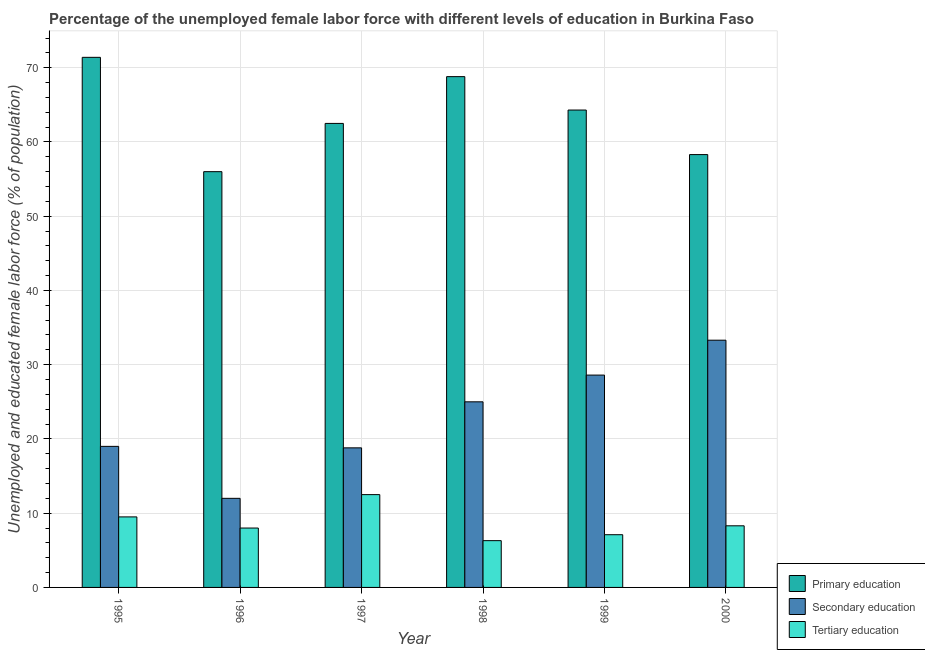How many different coloured bars are there?
Give a very brief answer. 3. Are the number of bars on each tick of the X-axis equal?
Your answer should be very brief. Yes. How many bars are there on the 4th tick from the right?
Offer a terse response. 3. What is the label of the 6th group of bars from the left?
Ensure brevity in your answer.  2000. In how many cases, is the number of bars for a given year not equal to the number of legend labels?
Give a very brief answer. 0. What is the percentage of female labor force who received tertiary education in 1999?
Keep it short and to the point. 7.1. Across all years, what is the minimum percentage of female labor force who received secondary education?
Your answer should be compact. 12. In which year was the percentage of female labor force who received secondary education minimum?
Ensure brevity in your answer.  1996. What is the total percentage of female labor force who received primary education in the graph?
Your answer should be compact. 381.3. What is the difference between the percentage of female labor force who received secondary education in 1996 and the percentage of female labor force who received tertiary education in 1995?
Keep it short and to the point. -7. What is the average percentage of female labor force who received tertiary education per year?
Your response must be concise. 8.62. In the year 2000, what is the difference between the percentage of female labor force who received tertiary education and percentage of female labor force who received primary education?
Keep it short and to the point. 0. In how many years, is the percentage of female labor force who received primary education greater than 32 %?
Make the answer very short. 6. What is the ratio of the percentage of female labor force who received primary education in 1996 to that in 2000?
Make the answer very short. 0.96. Is the percentage of female labor force who received tertiary education in 1995 less than that in 2000?
Offer a very short reply. No. What is the difference between the highest and the second highest percentage of female labor force who received tertiary education?
Your answer should be very brief. 3. What is the difference between the highest and the lowest percentage of female labor force who received tertiary education?
Ensure brevity in your answer.  6.2. What does the 1st bar from the left in 2000 represents?
Keep it short and to the point. Primary education. What does the 3rd bar from the right in 2000 represents?
Your answer should be very brief. Primary education. Are all the bars in the graph horizontal?
Provide a succinct answer. No. Are the values on the major ticks of Y-axis written in scientific E-notation?
Your answer should be compact. No. Does the graph contain any zero values?
Offer a terse response. No. How many legend labels are there?
Your answer should be very brief. 3. What is the title of the graph?
Your answer should be compact. Percentage of the unemployed female labor force with different levels of education in Burkina Faso. What is the label or title of the Y-axis?
Offer a terse response. Unemployed and educated female labor force (% of population). What is the Unemployed and educated female labor force (% of population) of Primary education in 1995?
Offer a very short reply. 71.4. What is the Unemployed and educated female labor force (% of population) of Tertiary education in 1995?
Offer a very short reply. 9.5. What is the Unemployed and educated female labor force (% of population) in Primary education in 1996?
Provide a succinct answer. 56. What is the Unemployed and educated female labor force (% of population) of Secondary education in 1996?
Offer a very short reply. 12. What is the Unemployed and educated female labor force (% of population) of Primary education in 1997?
Make the answer very short. 62.5. What is the Unemployed and educated female labor force (% of population) of Secondary education in 1997?
Provide a succinct answer. 18.8. What is the Unemployed and educated female labor force (% of population) of Tertiary education in 1997?
Provide a succinct answer. 12.5. What is the Unemployed and educated female labor force (% of population) in Primary education in 1998?
Your response must be concise. 68.8. What is the Unemployed and educated female labor force (% of population) of Secondary education in 1998?
Provide a short and direct response. 25. What is the Unemployed and educated female labor force (% of population) in Tertiary education in 1998?
Your response must be concise. 6.3. What is the Unemployed and educated female labor force (% of population) in Primary education in 1999?
Provide a succinct answer. 64.3. What is the Unemployed and educated female labor force (% of population) of Secondary education in 1999?
Make the answer very short. 28.6. What is the Unemployed and educated female labor force (% of population) of Tertiary education in 1999?
Provide a succinct answer. 7.1. What is the Unemployed and educated female labor force (% of population) in Primary education in 2000?
Keep it short and to the point. 58.3. What is the Unemployed and educated female labor force (% of population) of Secondary education in 2000?
Ensure brevity in your answer.  33.3. What is the Unemployed and educated female labor force (% of population) of Tertiary education in 2000?
Offer a terse response. 8.3. Across all years, what is the maximum Unemployed and educated female labor force (% of population) in Primary education?
Your answer should be very brief. 71.4. Across all years, what is the maximum Unemployed and educated female labor force (% of population) of Secondary education?
Make the answer very short. 33.3. Across all years, what is the maximum Unemployed and educated female labor force (% of population) of Tertiary education?
Offer a very short reply. 12.5. Across all years, what is the minimum Unemployed and educated female labor force (% of population) in Tertiary education?
Ensure brevity in your answer.  6.3. What is the total Unemployed and educated female labor force (% of population) of Primary education in the graph?
Provide a short and direct response. 381.3. What is the total Unemployed and educated female labor force (% of population) of Secondary education in the graph?
Make the answer very short. 136.7. What is the total Unemployed and educated female labor force (% of population) in Tertiary education in the graph?
Provide a short and direct response. 51.7. What is the difference between the Unemployed and educated female labor force (% of population) of Secondary education in 1995 and that in 1996?
Provide a succinct answer. 7. What is the difference between the Unemployed and educated female labor force (% of population) in Tertiary education in 1995 and that in 1996?
Provide a short and direct response. 1.5. What is the difference between the Unemployed and educated female labor force (% of population) of Tertiary education in 1995 and that in 1997?
Ensure brevity in your answer.  -3. What is the difference between the Unemployed and educated female labor force (% of population) in Secondary education in 1995 and that in 1998?
Make the answer very short. -6. What is the difference between the Unemployed and educated female labor force (% of population) in Primary education in 1995 and that in 1999?
Your answer should be very brief. 7.1. What is the difference between the Unemployed and educated female labor force (% of population) of Secondary education in 1995 and that in 1999?
Your answer should be compact. -9.6. What is the difference between the Unemployed and educated female labor force (% of population) of Primary education in 1995 and that in 2000?
Your response must be concise. 13.1. What is the difference between the Unemployed and educated female labor force (% of population) of Secondary education in 1995 and that in 2000?
Make the answer very short. -14.3. What is the difference between the Unemployed and educated female labor force (% of population) of Primary education in 1996 and that in 1997?
Your answer should be very brief. -6.5. What is the difference between the Unemployed and educated female labor force (% of population) of Primary education in 1996 and that in 1998?
Give a very brief answer. -12.8. What is the difference between the Unemployed and educated female labor force (% of population) of Primary education in 1996 and that in 1999?
Make the answer very short. -8.3. What is the difference between the Unemployed and educated female labor force (% of population) of Secondary education in 1996 and that in 1999?
Keep it short and to the point. -16.6. What is the difference between the Unemployed and educated female labor force (% of population) of Secondary education in 1996 and that in 2000?
Offer a very short reply. -21.3. What is the difference between the Unemployed and educated female labor force (% of population) in Tertiary education in 1996 and that in 2000?
Make the answer very short. -0.3. What is the difference between the Unemployed and educated female labor force (% of population) of Secondary education in 1997 and that in 1998?
Provide a succinct answer. -6.2. What is the difference between the Unemployed and educated female labor force (% of population) in Tertiary education in 1997 and that in 1998?
Offer a terse response. 6.2. What is the difference between the Unemployed and educated female labor force (% of population) in Secondary education in 1997 and that in 1999?
Ensure brevity in your answer.  -9.8. What is the difference between the Unemployed and educated female labor force (% of population) of Tertiary education in 1997 and that in 1999?
Offer a terse response. 5.4. What is the difference between the Unemployed and educated female labor force (% of population) of Secondary education in 1997 and that in 2000?
Keep it short and to the point. -14.5. What is the difference between the Unemployed and educated female labor force (% of population) in Tertiary education in 1997 and that in 2000?
Offer a very short reply. 4.2. What is the difference between the Unemployed and educated female labor force (% of population) of Primary education in 1998 and that in 1999?
Ensure brevity in your answer.  4.5. What is the difference between the Unemployed and educated female labor force (% of population) in Primary education in 1998 and that in 2000?
Give a very brief answer. 10.5. What is the difference between the Unemployed and educated female labor force (% of population) of Primary education in 1999 and that in 2000?
Keep it short and to the point. 6. What is the difference between the Unemployed and educated female labor force (% of population) in Primary education in 1995 and the Unemployed and educated female labor force (% of population) in Secondary education in 1996?
Your answer should be very brief. 59.4. What is the difference between the Unemployed and educated female labor force (% of population) of Primary education in 1995 and the Unemployed and educated female labor force (% of population) of Tertiary education in 1996?
Make the answer very short. 63.4. What is the difference between the Unemployed and educated female labor force (% of population) in Secondary education in 1995 and the Unemployed and educated female labor force (% of population) in Tertiary education in 1996?
Provide a succinct answer. 11. What is the difference between the Unemployed and educated female labor force (% of population) of Primary education in 1995 and the Unemployed and educated female labor force (% of population) of Secondary education in 1997?
Keep it short and to the point. 52.6. What is the difference between the Unemployed and educated female labor force (% of population) of Primary education in 1995 and the Unemployed and educated female labor force (% of population) of Tertiary education in 1997?
Your answer should be compact. 58.9. What is the difference between the Unemployed and educated female labor force (% of population) of Secondary education in 1995 and the Unemployed and educated female labor force (% of population) of Tertiary education in 1997?
Your response must be concise. 6.5. What is the difference between the Unemployed and educated female labor force (% of population) of Primary education in 1995 and the Unemployed and educated female labor force (% of population) of Secondary education in 1998?
Your response must be concise. 46.4. What is the difference between the Unemployed and educated female labor force (% of population) in Primary education in 1995 and the Unemployed and educated female labor force (% of population) in Tertiary education in 1998?
Keep it short and to the point. 65.1. What is the difference between the Unemployed and educated female labor force (% of population) in Primary education in 1995 and the Unemployed and educated female labor force (% of population) in Secondary education in 1999?
Your response must be concise. 42.8. What is the difference between the Unemployed and educated female labor force (% of population) in Primary education in 1995 and the Unemployed and educated female labor force (% of population) in Tertiary education in 1999?
Ensure brevity in your answer.  64.3. What is the difference between the Unemployed and educated female labor force (% of population) of Secondary education in 1995 and the Unemployed and educated female labor force (% of population) of Tertiary education in 1999?
Keep it short and to the point. 11.9. What is the difference between the Unemployed and educated female labor force (% of population) of Primary education in 1995 and the Unemployed and educated female labor force (% of population) of Secondary education in 2000?
Give a very brief answer. 38.1. What is the difference between the Unemployed and educated female labor force (% of population) in Primary education in 1995 and the Unemployed and educated female labor force (% of population) in Tertiary education in 2000?
Provide a short and direct response. 63.1. What is the difference between the Unemployed and educated female labor force (% of population) in Primary education in 1996 and the Unemployed and educated female labor force (% of population) in Secondary education in 1997?
Keep it short and to the point. 37.2. What is the difference between the Unemployed and educated female labor force (% of population) in Primary education in 1996 and the Unemployed and educated female labor force (% of population) in Tertiary education in 1997?
Provide a succinct answer. 43.5. What is the difference between the Unemployed and educated female labor force (% of population) in Secondary education in 1996 and the Unemployed and educated female labor force (% of population) in Tertiary education in 1997?
Your answer should be very brief. -0.5. What is the difference between the Unemployed and educated female labor force (% of population) in Primary education in 1996 and the Unemployed and educated female labor force (% of population) in Secondary education in 1998?
Your answer should be compact. 31. What is the difference between the Unemployed and educated female labor force (% of population) in Primary education in 1996 and the Unemployed and educated female labor force (% of population) in Tertiary education in 1998?
Offer a very short reply. 49.7. What is the difference between the Unemployed and educated female labor force (% of population) of Secondary education in 1996 and the Unemployed and educated female labor force (% of population) of Tertiary education in 1998?
Your answer should be very brief. 5.7. What is the difference between the Unemployed and educated female labor force (% of population) in Primary education in 1996 and the Unemployed and educated female labor force (% of population) in Secondary education in 1999?
Your answer should be compact. 27.4. What is the difference between the Unemployed and educated female labor force (% of population) of Primary education in 1996 and the Unemployed and educated female labor force (% of population) of Tertiary education in 1999?
Provide a succinct answer. 48.9. What is the difference between the Unemployed and educated female labor force (% of population) of Secondary education in 1996 and the Unemployed and educated female labor force (% of population) of Tertiary education in 1999?
Give a very brief answer. 4.9. What is the difference between the Unemployed and educated female labor force (% of population) in Primary education in 1996 and the Unemployed and educated female labor force (% of population) in Secondary education in 2000?
Give a very brief answer. 22.7. What is the difference between the Unemployed and educated female labor force (% of population) in Primary education in 1996 and the Unemployed and educated female labor force (% of population) in Tertiary education in 2000?
Make the answer very short. 47.7. What is the difference between the Unemployed and educated female labor force (% of population) in Primary education in 1997 and the Unemployed and educated female labor force (% of population) in Secondary education in 1998?
Give a very brief answer. 37.5. What is the difference between the Unemployed and educated female labor force (% of population) of Primary education in 1997 and the Unemployed and educated female labor force (% of population) of Tertiary education in 1998?
Provide a succinct answer. 56.2. What is the difference between the Unemployed and educated female labor force (% of population) in Primary education in 1997 and the Unemployed and educated female labor force (% of population) in Secondary education in 1999?
Ensure brevity in your answer.  33.9. What is the difference between the Unemployed and educated female labor force (% of population) in Primary education in 1997 and the Unemployed and educated female labor force (% of population) in Tertiary education in 1999?
Offer a very short reply. 55.4. What is the difference between the Unemployed and educated female labor force (% of population) in Primary education in 1997 and the Unemployed and educated female labor force (% of population) in Secondary education in 2000?
Your answer should be compact. 29.2. What is the difference between the Unemployed and educated female labor force (% of population) in Primary education in 1997 and the Unemployed and educated female labor force (% of population) in Tertiary education in 2000?
Your response must be concise. 54.2. What is the difference between the Unemployed and educated female labor force (% of population) of Secondary education in 1997 and the Unemployed and educated female labor force (% of population) of Tertiary education in 2000?
Give a very brief answer. 10.5. What is the difference between the Unemployed and educated female labor force (% of population) in Primary education in 1998 and the Unemployed and educated female labor force (% of population) in Secondary education in 1999?
Your answer should be very brief. 40.2. What is the difference between the Unemployed and educated female labor force (% of population) of Primary education in 1998 and the Unemployed and educated female labor force (% of population) of Tertiary education in 1999?
Provide a succinct answer. 61.7. What is the difference between the Unemployed and educated female labor force (% of population) of Secondary education in 1998 and the Unemployed and educated female labor force (% of population) of Tertiary education in 1999?
Provide a short and direct response. 17.9. What is the difference between the Unemployed and educated female labor force (% of population) of Primary education in 1998 and the Unemployed and educated female labor force (% of population) of Secondary education in 2000?
Provide a short and direct response. 35.5. What is the difference between the Unemployed and educated female labor force (% of population) in Primary education in 1998 and the Unemployed and educated female labor force (% of population) in Tertiary education in 2000?
Provide a short and direct response. 60.5. What is the difference between the Unemployed and educated female labor force (% of population) in Primary education in 1999 and the Unemployed and educated female labor force (% of population) in Tertiary education in 2000?
Provide a succinct answer. 56. What is the difference between the Unemployed and educated female labor force (% of population) of Secondary education in 1999 and the Unemployed and educated female labor force (% of population) of Tertiary education in 2000?
Your answer should be compact. 20.3. What is the average Unemployed and educated female labor force (% of population) of Primary education per year?
Your response must be concise. 63.55. What is the average Unemployed and educated female labor force (% of population) in Secondary education per year?
Offer a very short reply. 22.78. What is the average Unemployed and educated female labor force (% of population) in Tertiary education per year?
Your answer should be compact. 8.62. In the year 1995, what is the difference between the Unemployed and educated female labor force (% of population) in Primary education and Unemployed and educated female labor force (% of population) in Secondary education?
Give a very brief answer. 52.4. In the year 1995, what is the difference between the Unemployed and educated female labor force (% of population) of Primary education and Unemployed and educated female labor force (% of population) of Tertiary education?
Provide a short and direct response. 61.9. In the year 1996, what is the difference between the Unemployed and educated female labor force (% of population) of Primary education and Unemployed and educated female labor force (% of population) of Secondary education?
Make the answer very short. 44. In the year 1996, what is the difference between the Unemployed and educated female labor force (% of population) of Secondary education and Unemployed and educated female labor force (% of population) of Tertiary education?
Offer a terse response. 4. In the year 1997, what is the difference between the Unemployed and educated female labor force (% of population) of Primary education and Unemployed and educated female labor force (% of population) of Secondary education?
Ensure brevity in your answer.  43.7. In the year 1998, what is the difference between the Unemployed and educated female labor force (% of population) of Primary education and Unemployed and educated female labor force (% of population) of Secondary education?
Offer a very short reply. 43.8. In the year 1998, what is the difference between the Unemployed and educated female labor force (% of population) in Primary education and Unemployed and educated female labor force (% of population) in Tertiary education?
Make the answer very short. 62.5. In the year 1998, what is the difference between the Unemployed and educated female labor force (% of population) in Secondary education and Unemployed and educated female labor force (% of population) in Tertiary education?
Your answer should be compact. 18.7. In the year 1999, what is the difference between the Unemployed and educated female labor force (% of population) in Primary education and Unemployed and educated female labor force (% of population) in Secondary education?
Make the answer very short. 35.7. In the year 1999, what is the difference between the Unemployed and educated female labor force (% of population) in Primary education and Unemployed and educated female labor force (% of population) in Tertiary education?
Give a very brief answer. 57.2. In the year 1999, what is the difference between the Unemployed and educated female labor force (% of population) in Secondary education and Unemployed and educated female labor force (% of population) in Tertiary education?
Make the answer very short. 21.5. In the year 2000, what is the difference between the Unemployed and educated female labor force (% of population) in Primary education and Unemployed and educated female labor force (% of population) in Tertiary education?
Your answer should be very brief. 50. In the year 2000, what is the difference between the Unemployed and educated female labor force (% of population) of Secondary education and Unemployed and educated female labor force (% of population) of Tertiary education?
Offer a very short reply. 25. What is the ratio of the Unemployed and educated female labor force (% of population) in Primary education in 1995 to that in 1996?
Offer a terse response. 1.27. What is the ratio of the Unemployed and educated female labor force (% of population) in Secondary education in 1995 to that in 1996?
Keep it short and to the point. 1.58. What is the ratio of the Unemployed and educated female labor force (% of population) of Tertiary education in 1995 to that in 1996?
Provide a short and direct response. 1.19. What is the ratio of the Unemployed and educated female labor force (% of population) in Primary education in 1995 to that in 1997?
Your answer should be compact. 1.14. What is the ratio of the Unemployed and educated female labor force (% of population) in Secondary education in 1995 to that in 1997?
Ensure brevity in your answer.  1.01. What is the ratio of the Unemployed and educated female labor force (% of population) of Tertiary education in 1995 to that in 1997?
Give a very brief answer. 0.76. What is the ratio of the Unemployed and educated female labor force (% of population) of Primary education in 1995 to that in 1998?
Your answer should be compact. 1.04. What is the ratio of the Unemployed and educated female labor force (% of population) of Secondary education in 1995 to that in 1998?
Offer a very short reply. 0.76. What is the ratio of the Unemployed and educated female labor force (% of population) in Tertiary education in 1995 to that in 1998?
Your answer should be compact. 1.51. What is the ratio of the Unemployed and educated female labor force (% of population) of Primary education in 1995 to that in 1999?
Ensure brevity in your answer.  1.11. What is the ratio of the Unemployed and educated female labor force (% of population) of Secondary education in 1995 to that in 1999?
Your response must be concise. 0.66. What is the ratio of the Unemployed and educated female labor force (% of population) in Tertiary education in 1995 to that in 1999?
Keep it short and to the point. 1.34. What is the ratio of the Unemployed and educated female labor force (% of population) in Primary education in 1995 to that in 2000?
Your answer should be very brief. 1.22. What is the ratio of the Unemployed and educated female labor force (% of population) in Secondary education in 1995 to that in 2000?
Provide a short and direct response. 0.57. What is the ratio of the Unemployed and educated female labor force (% of population) in Tertiary education in 1995 to that in 2000?
Provide a succinct answer. 1.14. What is the ratio of the Unemployed and educated female labor force (% of population) of Primary education in 1996 to that in 1997?
Keep it short and to the point. 0.9. What is the ratio of the Unemployed and educated female labor force (% of population) of Secondary education in 1996 to that in 1997?
Give a very brief answer. 0.64. What is the ratio of the Unemployed and educated female labor force (% of population) in Tertiary education in 1996 to that in 1997?
Provide a succinct answer. 0.64. What is the ratio of the Unemployed and educated female labor force (% of population) of Primary education in 1996 to that in 1998?
Offer a terse response. 0.81. What is the ratio of the Unemployed and educated female labor force (% of population) of Secondary education in 1996 to that in 1998?
Offer a very short reply. 0.48. What is the ratio of the Unemployed and educated female labor force (% of population) of Tertiary education in 1996 to that in 1998?
Your response must be concise. 1.27. What is the ratio of the Unemployed and educated female labor force (% of population) in Primary education in 1996 to that in 1999?
Ensure brevity in your answer.  0.87. What is the ratio of the Unemployed and educated female labor force (% of population) of Secondary education in 1996 to that in 1999?
Offer a terse response. 0.42. What is the ratio of the Unemployed and educated female labor force (% of population) in Tertiary education in 1996 to that in 1999?
Your response must be concise. 1.13. What is the ratio of the Unemployed and educated female labor force (% of population) in Primary education in 1996 to that in 2000?
Your response must be concise. 0.96. What is the ratio of the Unemployed and educated female labor force (% of population) in Secondary education in 1996 to that in 2000?
Your response must be concise. 0.36. What is the ratio of the Unemployed and educated female labor force (% of population) in Tertiary education in 1996 to that in 2000?
Your answer should be very brief. 0.96. What is the ratio of the Unemployed and educated female labor force (% of population) in Primary education in 1997 to that in 1998?
Make the answer very short. 0.91. What is the ratio of the Unemployed and educated female labor force (% of population) in Secondary education in 1997 to that in 1998?
Make the answer very short. 0.75. What is the ratio of the Unemployed and educated female labor force (% of population) of Tertiary education in 1997 to that in 1998?
Make the answer very short. 1.98. What is the ratio of the Unemployed and educated female labor force (% of population) of Primary education in 1997 to that in 1999?
Your answer should be compact. 0.97. What is the ratio of the Unemployed and educated female labor force (% of population) of Secondary education in 1997 to that in 1999?
Your answer should be compact. 0.66. What is the ratio of the Unemployed and educated female labor force (% of population) in Tertiary education in 1997 to that in 1999?
Give a very brief answer. 1.76. What is the ratio of the Unemployed and educated female labor force (% of population) of Primary education in 1997 to that in 2000?
Make the answer very short. 1.07. What is the ratio of the Unemployed and educated female labor force (% of population) in Secondary education in 1997 to that in 2000?
Provide a succinct answer. 0.56. What is the ratio of the Unemployed and educated female labor force (% of population) in Tertiary education in 1997 to that in 2000?
Ensure brevity in your answer.  1.51. What is the ratio of the Unemployed and educated female labor force (% of population) of Primary education in 1998 to that in 1999?
Offer a very short reply. 1.07. What is the ratio of the Unemployed and educated female labor force (% of population) in Secondary education in 1998 to that in 1999?
Your answer should be compact. 0.87. What is the ratio of the Unemployed and educated female labor force (% of population) of Tertiary education in 1998 to that in 1999?
Provide a short and direct response. 0.89. What is the ratio of the Unemployed and educated female labor force (% of population) of Primary education in 1998 to that in 2000?
Ensure brevity in your answer.  1.18. What is the ratio of the Unemployed and educated female labor force (% of population) of Secondary education in 1998 to that in 2000?
Your answer should be compact. 0.75. What is the ratio of the Unemployed and educated female labor force (% of population) of Tertiary education in 1998 to that in 2000?
Make the answer very short. 0.76. What is the ratio of the Unemployed and educated female labor force (% of population) in Primary education in 1999 to that in 2000?
Provide a succinct answer. 1.1. What is the ratio of the Unemployed and educated female labor force (% of population) in Secondary education in 1999 to that in 2000?
Ensure brevity in your answer.  0.86. What is the ratio of the Unemployed and educated female labor force (% of population) of Tertiary education in 1999 to that in 2000?
Ensure brevity in your answer.  0.86. What is the difference between the highest and the second highest Unemployed and educated female labor force (% of population) of Secondary education?
Give a very brief answer. 4.7. What is the difference between the highest and the lowest Unemployed and educated female labor force (% of population) in Primary education?
Your response must be concise. 15.4. What is the difference between the highest and the lowest Unemployed and educated female labor force (% of population) in Secondary education?
Provide a succinct answer. 21.3. What is the difference between the highest and the lowest Unemployed and educated female labor force (% of population) in Tertiary education?
Your response must be concise. 6.2. 